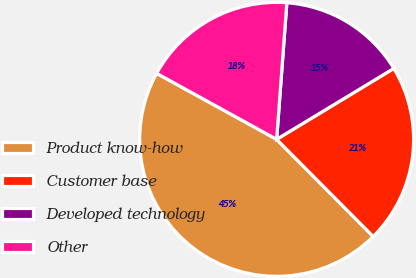Convert chart to OTSL. <chart><loc_0><loc_0><loc_500><loc_500><pie_chart><fcel>Product know-how<fcel>Customer base<fcel>Developed technology<fcel>Other<nl><fcel>45.45%<fcel>21.21%<fcel>15.15%<fcel>18.18%<nl></chart> 